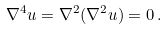<formula> <loc_0><loc_0><loc_500><loc_500>\nabla ^ { 4 } u = \nabla ^ { 2 } ( \nabla ^ { 2 } u ) = 0 \, .</formula> 